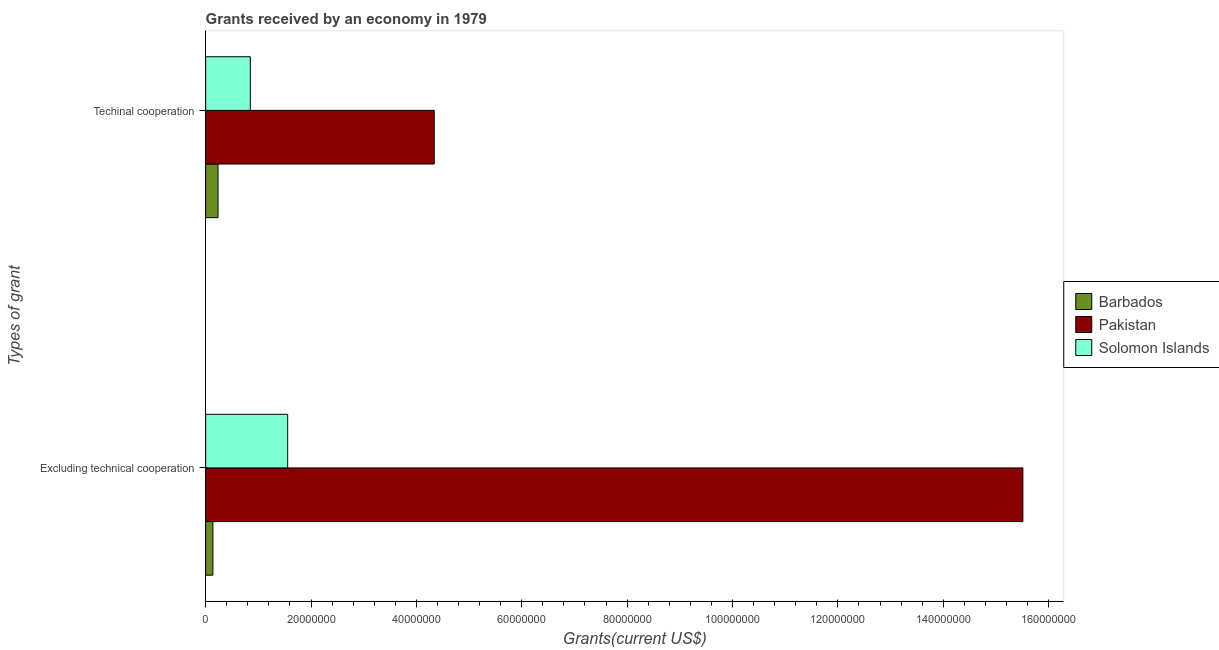How many groups of bars are there?
Your answer should be compact. 2. Are the number of bars on each tick of the Y-axis equal?
Provide a succinct answer. Yes. What is the label of the 1st group of bars from the top?
Offer a terse response. Techinal cooperation. What is the amount of grants received(excluding technical cooperation) in Barbados?
Ensure brevity in your answer.  1.38e+06. Across all countries, what is the maximum amount of grants received(excluding technical cooperation)?
Make the answer very short. 1.55e+08. Across all countries, what is the minimum amount of grants received(including technical cooperation)?
Keep it short and to the point. 2.35e+06. In which country was the amount of grants received(including technical cooperation) maximum?
Offer a terse response. Pakistan. In which country was the amount of grants received(excluding technical cooperation) minimum?
Offer a terse response. Barbados. What is the total amount of grants received(excluding technical cooperation) in the graph?
Ensure brevity in your answer.  1.72e+08. What is the difference between the amount of grants received(including technical cooperation) in Pakistan and that in Solomon Islands?
Make the answer very short. 3.49e+07. What is the difference between the amount of grants received(including technical cooperation) in Solomon Islands and the amount of grants received(excluding technical cooperation) in Barbados?
Give a very brief answer. 7.10e+06. What is the average amount of grants received(excluding technical cooperation) per country?
Keep it short and to the point. 5.74e+07. What is the difference between the amount of grants received(including technical cooperation) and amount of grants received(excluding technical cooperation) in Pakistan?
Provide a succinct answer. -1.12e+08. What is the ratio of the amount of grants received(including technical cooperation) in Solomon Islands to that in Pakistan?
Provide a short and direct response. 0.2. In how many countries, is the amount of grants received(including technical cooperation) greater than the average amount of grants received(including technical cooperation) taken over all countries?
Make the answer very short. 1. What does the 1st bar from the top in Excluding technical cooperation represents?
Give a very brief answer. Solomon Islands. What does the 3rd bar from the bottom in Techinal cooperation represents?
Offer a very short reply. Solomon Islands. How many bars are there?
Keep it short and to the point. 6. Are all the bars in the graph horizontal?
Your response must be concise. Yes. Are the values on the major ticks of X-axis written in scientific E-notation?
Offer a very short reply. No. Does the graph contain any zero values?
Your answer should be very brief. No. Does the graph contain grids?
Provide a short and direct response. No. How many legend labels are there?
Make the answer very short. 3. How are the legend labels stacked?
Your answer should be very brief. Vertical. What is the title of the graph?
Your answer should be very brief. Grants received by an economy in 1979. Does "Turkey" appear as one of the legend labels in the graph?
Your answer should be very brief. No. What is the label or title of the X-axis?
Give a very brief answer. Grants(current US$). What is the label or title of the Y-axis?
Your answer should be very brief. Types of grant. What is the Grants(current US$) in Barbados in Excluding technical cooperation?
Provide a succinct answer. 1.38e+06. What is the Grants(current US$) of Pakistan in Excluding technical cooperation?
Provide a succinct answer. 1.55e+08. What is the Grants(current US$) of Solomon Islands in Excluding technical cooperation?
Your answer should be very brief. 1.56e+07. What is the Grants(current US$) in Barbados in Techinal cooperation?
Offer a very short reply. 2.35e+06. What is the Grants(current US$) in Pakistan in Techinal cooperation?
Provide a succinct answer. 4.34e+07. What is the Grants(current US$) in Solomon Islands in Techinal cooperation?
Offer a very short reply. 8.48e+06. Across all Types of grant, what is the maximum Grants(current US$) in Barbados?
Your response must be concise. 2.35e+06. Across all Types of grant, what is the maximum Grants(current US$) of Pakistan?
Ensure brevity in your answer.  1.55e+08. Across all Types of grant, what is the maximum Grants(current US$) in Solomon Islands?
Offer a terse response. 1.56e+07. Across all Types of grant, what is the minimum Grants(current US$) of Barbados?
Make the answer very short. 1.38e+06. Across all Types of grant, what is the minimum Grants(current US$) of Pakistan?
Offer a terse response. 4.34e+07. Across all Types of grant, what is the minimum Grants(current US$) of Solomon Islands?
Offer a very short reply. 8.48e+06. What is the total Grants(current US$) of Barbados in the graph?
Your response must be concise. 3.73e+06. What is the total Grants(current US$) of Pakistan in the graph?
Your answer should be compact. 1.99e+08. What is the total Grants(current US$) in Solomon Islands in the graph?
Offer a terse response. 2.40e+07. What is the difference between the Grants(current US$) of Barbados in Excluding technical cooperation and that in Techinal cooperation?
Offer a very short reply. -9.70e+05. What is the difference between the Grants(current US$) of Pakistan in Excluding technical cooperation and that in Techinal cooperation?
Give a very brief answer. 1.12e+08. What is the difference between the Grants(current US$) in Solomon Islands in Excluding technical cooperation and that in Techinal cooperation?
Your response must be concise. 7.09e+06. What is the difference between the Grants(current US$) of Barbados in Excluding technical cooperation and the Grants(current US$) of Pakistan in Techinal cooperation?
Your answer should be very brief. -4.20e+07. What is the difference between the Grants(current US$) in Barbados in Excluding technical cooperation and the Grants(current US$) in Solomon Islands in Techinal cooperation?
Give a very brief answer. -7.10e+06. What is the difference between the Grants(current US$) in Pakistan in Excluding technical cooperation and the Grants(current US$) in Solomon Islands in Techinal cooperation?
Make the answer very short. 1.47e+08. What is the average Grants(current US$) in Barbados per Types of grant?
Your answer should be compact. 1.86e+06. What is the average Grants(current US$) in Pakistan per Types of grant?
Make the answer very short. 9.93e+07. What is the average Grants(current US$) in Solomon Islands per Types of grant?
Provide a short and direct response. 1.20e+07. What is the difference between the Grants(current US$) in Barbados and Grants(current US$) in Pakistan in Excluding technical cooperation?
Offer a very short reply. -1.54e+08. What is the difference between the Grants(current US$) of Barbados and Grants(current US$) of Solomon Islands in Excluding technical cooperation?
Make the answer very short. -1.42e+07. What is the difference between the Grants(current US$) of Pakistan and Grants(current US$) of Solomon Islands in Excluding technical cooperation?
Offer a terse response. 1.40e+08. What is the difference between the Grants(current US$) in Barbados and Grants(current US$) in Pakistan in Techinal cooperation?
Your answer should be very brief. -4.10e+07. What is the difference between the Grants(current US$) in Barbados and Grants(current US$) in Solomon Islands in Techinal cooperation?
Your answer should be compact. -6.13e+06. What is the difference between the Grants(current US$) in Pakistan and Grants(current US$) in Solomon Islands in Techinal cooperation?
Offer a terse response. 3.49e+07. What is the ratio of the Grants(current US$) of Barbados in Excluding technical cooperation to that in Techinal cooperation?
Offer a very short reply. 0.59. What is the ratio of the Grants(current US$) in Pakistan in Excluding technical cooperation to that in Techinal cooperation?
Ensure brevity in your answer.  3.58. What is the ratio of the Grants(current US$) in Solomon Islands in Excluding technical cooperation to that in Techinal cooperation?
Make the answer very short. 1.84. What is the difference between the highest and the second highest Grants(current US$) in Barbados?
Provide a short and direct response. 9.70e+05. What is the difference between the highest and the second highest Grants(current US$) in Pakistan?
Ensure brevity in your answer.  1.12e+08. What is the difference between the highest and the second highest Grants(current US$) of Solomon Islands?
Keep it short and to the point. 7.09e+06. What is the difference between the highest and the lowest Grants(current US$) in Barbados?
Offer a terse response. 9.70e+05. What is the difference between the highest and the lowest Grants(current US$) in Pakistan?
Make the answer very short. 1.12e+08. What is the difference between the highest and the lowest Grants(current US$) in Solomon Islands?
Ensure brevity in your answer.  7.09e+06. 